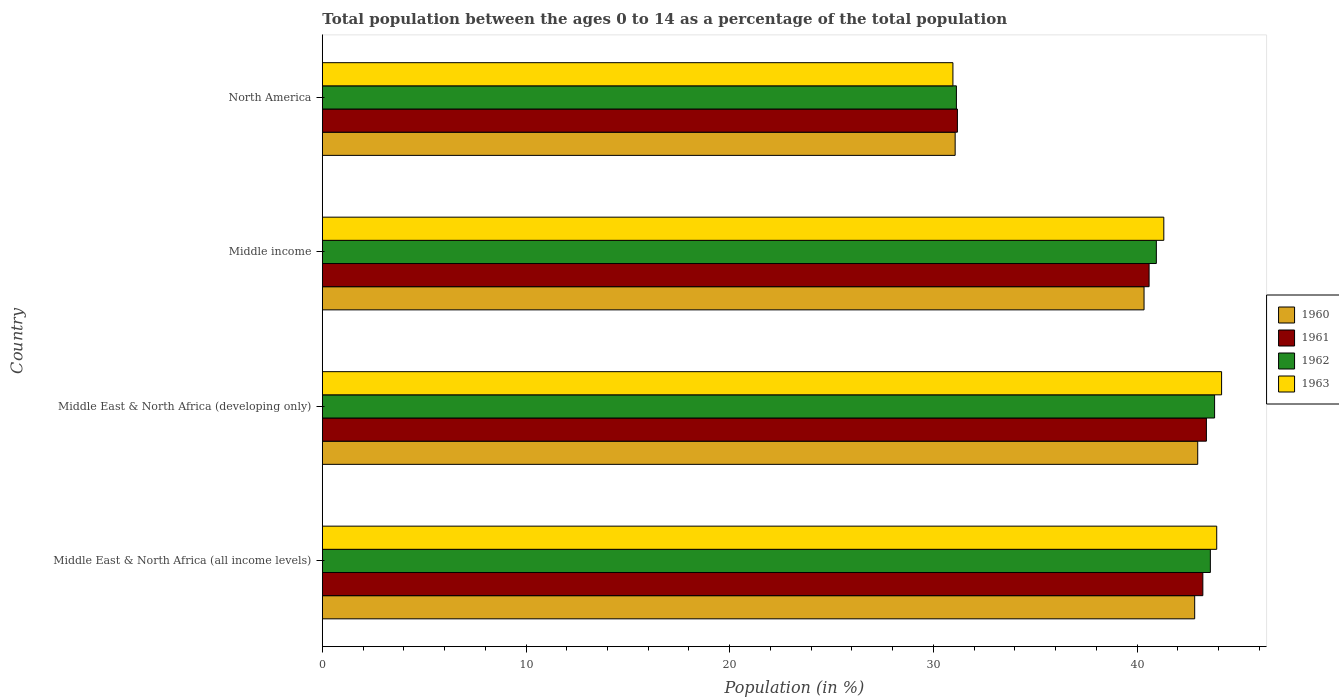How many different coloured bars are there?
Offer a terse response. 4. Are the number of bars on each tick of the Y-axis equal?
Make the answer very short. Yes. In how many cases, is the number of bars for a given country not equal to the number of legend labels?
Provide a succinct answer. 0. What is the percentage of the population ages 0 to 14 in 1961 in North America?
Your answer should be very brief. 31.18. Across all countries, what is the maximum percentage of the population ages 0 to 14 in 1960?
Ensure brevity in your answer.  42.97. Across all countries, what is the minimum percentage of the population ages 0 to 14 in 1963?
Your response must be concise. 30.96. In which country was the percentage of the population ages 0 to 14 in 1962 maximum?
Ensure brevity in your answer.  Middle East & North Africa (developing only). In which country was the percentage of the population ages 0 to 14 in 1961 minimum?
Make the answer very short. North America. What is the total percentage of the population ages 0 to 14 in 1961 in the graph?
Your answer should be very brief. 158.39. What is the difference between the percentage of the population ages 0 to 14 in 1961 in Middle East & North Africa (all income levels) and that in North America?
Provide a short and direct response. 12.05. What is the difference between the percentage of the population ages 0 to 14 in 1961 in Middle East & North Africa (all income levels) and the percentage of the population ages 0 to 14 in 1960 in Middle East & North Africa (developing only)?
Provide a short and direct response. 0.25. What is the average percentage of the population ages 0 to 14 in 1963 per country?
Provide a short and direct response. 40.08. What is the difference between the percentage of the population ages 0 to 14 in 1963 and percentage of the population ages 0 to 14 in 1962 in Middle income?
Provide a short and direct response. 0.37. In how many countries, is the percentage of the population ages 0 to 14 in 1962 greater than 38 ?
Make the answer very short. 3. What is the ratio of the percentage of the population ages 0 to 14 in 1961 in Middle East & North Africa (all income levels) to that in North America?
Your answer should be very brief. 1.39. Is the percentage of the population ages 0 to 14 in 1963 in Middle East & North Africa (all income levels) less than that in Middle East & North Africa (developing only)?
Give a very brief answer. Yes. Is the difference between the percentage of the population ages 0 to 14 in 1963 in Middle East & North Africa (all income levels) and North America greater than the difference between the percentage of the population ages 0 to 14 in 1962 in Middle East & North Africa (all income levels) and North America?
Your answer should be very brief. Yes. What is the difference between the highest and the second highest percentage of the population ages 0 to 14 in 1963?
Make the answer very short. 0.24. What is the difference between the highest and the lowest percentage of the population ages 0 to 14 in 1963?
Make the answer very short. 13.19. In how many countries, is the percentage of the population ages 0 to 14 in 1962 greater than the average percentage of the population ages 0 to 14 in 1962 taken over all countries?
Ensure brevity in your answer.  3. Is it the case that in every country, the sum of the percentage of the population ages 0 to 14 in 1960 and percentage of the population ages 0 to 14 in 1962 is greater than the sum of percentage of the population ages 0 to 14 in 1961 and percentage of the population ages 0 to 14 in 1963?
Make the answer very short. No. What does the 1st bar from the top in Middle income represents?
Ensure brevity in your answer.  1963. How many countries are there in the graph?
Your answer should be very brief. 4. What is the difference between two consecutive major ticks on the X-axis?
Provide a short and direct response. 10. Are the values on the major ticks of X-axis written in scientific E-notation?
Provide a succinct answer. No. Does the graph contain any zero values?
Ensure brevity in your answer.  No. Does the graph contain grids?
Your response must be concise. No. Where does the legend appear in the graph?
Make the answer very short. Center right. How many legend labels are there?
Your answer should be compact. 4. What is the title of the graph?
Provide a succinct answer. Total population between the ages 0 to 14 as a percentage of the total population. Does "1975" appear as one of the legend labels in the graph?
Offer a terse response. No. What is the label or title of the Y-axis?
Offer a terse response. Country. What is the Population (in %) of 1960 in Middle East & North Africa (all income levels)?
Offer a terse response. 42.83. What is the Population (in %) of 1961 in Middle East & North Africa (all income levels)?
Offer a terse response. 43.23. What is the Population (in %) of 1962 in Middle East & North Africa (all income levels)?
Offer a terse response. 43.6. What is the Population (in %) of 1963 in Middle East & North Africa (all income levels)?
Provide a succinct answer. 43.91. What is the Population (in %) in 1960 in Middle East & North Africa (developing only)?
Offer a very short reply. 42.97. What is the Population (in %) of 1961 in Middle East & North Africa (developing only)?
Keep it short and to the point. 43.4. What is the Population (in %) of 1962 in Middle East & North Africa (developing only)?
Make the answer very short. 43.8. What is the Population (in %) of 1963 in Middle East & North Africa (developing only)?
Ensure brevity in your answer.  44.15. What is the Population (in %) of 1960 in Middle income?
Offer a terse response. 40.34. What is the Population (in %) in 1961 in Middle income?
Offer a very short reply. 40.59. What is the Population (in %) in 1962 in Middle income?
Your answer should be compact. 40.94. What is the Population (in %) in 1963 in Middle income?
Your answer should be compact. 41.31. What is the Population (in %) in 1960 in North America?
Make the answer very short. 31.07. What is the Population (in %) in 1961 in North America?
Ensure brevity in your answer.  31.18. What is the Population (in %) in 1962 in North America?
Provide a succinct answer. 31.13. What is the Population (in %) in 1963 in North America?
Your response must be concise. 30.96. Across all countries, what is the maximum Population (in %) of 1960?
Offer a terse response. 42.97. Across all countries, what is the maximum Population (in %) in 1961?
Provide a succinct answer. 43.4. Across all countries, what is the maximum Population (in %) of 1962?
Keep it short and to the point. 43.8. Across all countries, what is the maximum Population (in %) in 1963?
Your answer should be compact. 44.15. Across all countries, what is the minimum Population (in %) of 1960?
Your answer should be compact. 31.07. Across all countries, what is the minimum Population (in %) in 1961?
Offer a terse response. 31.18. Across all countries, what is the minimum Population (in %) of 1962?
Offer a terse response. 31.13. Across all countries, what is the minimum Population (in %) of 1963?
Your answer should be compact. 30.96. What is the total Population (in %) of 1960 in the graph?
Offer a very short reply. 157.21. What is the total Population (in %) of 1961 in the graph?
Keep it short and to the point. 158.39. What is the total Population (in %) in 1962 in the graph?
Ensure brevity in your answer.  159.47. What is the total Population (in %) in 1963 in the graph?
Your answer should be very brief. 160.32. What is the difference between the Population (in %) in 1960 in Middle East & North Africa (all income levels) and that in Middle East & North Africa (developing only)?
Provide a succinct answer. -0.15. What is the difference between the Population (in %) in 1961 in Middle East & North Africa (all income levels) and that in Middle East & North Africa (developing only)?
Offer a very short reply. -0.17. What is the difference between the Population (in %) in 1962 in Middle East & North Africa (all income levels) and that in Middle East & North Africa (developing only)?
Make the answer very short. -0.21. What is the difference between the Population (in %) in 1963 in Middle East & North Africa (all income levels) and that in Middle East & North Africa (developing only)?
Your response must be concise. -0.24. What is the difference between the Population (in %) in 1960 in Middle East & North Africa (all income levels) and that in Middle income?
Keep it short and to the point. 2.49. What is the difference between the Population (in %) of 1961 in Middle East & North Africa (all income levels) and that in Middle income?
Ensure brevity in your answer.  2.64. What is the difference between the Population (in %) in 1962 in Middle East & North Africa (all income levels) and that in Middle income?
Your answer should be compact. 2.65. What is the difference between the Population (in %) in 1963 in Middle East & North Africa (all income levels) and that in Middle income?
Offer a terse response. 2.6. What is the difference between the Population (in %) in 1960 in Middle East & North Africa (all income levels) and that in North America?
Your response must be concise. 11.76. What is the difference between the Population (in %) in 1961 in Middle East & North Africa (all income levels) and that in North America?
Give a very brief answer. 12.05. What is the difference between the Population (in %) of 1962 in Middle East & North Africa (all income levels) and that in North America?
Make the answer very short. 12.47. What is the difference between the Population (in %) of 1963 in Middle East & North Africa (all income levels) and that in North America?
Make the answer very short. 12.95. What is the difference between the Population (in %) in 1960 in Middle East & North Africa (developing only) and that in Middle income?
Offer a terse response. 2.63. What is the difference between the Population (in %) in 1961 in Middle East & North Africa (developing only) and that in Middle income?
Your answer should be very brief. 2.81. What is the difference between the Population (in %) of 1962 in Middle East & North Africa (developing only) and that in Middle income?
Provide a short and direct response. 2.86. What is the difference between the Population (in %) of 1963 in Middle East & North Africa (developing only) and that in Middle income?
Ensure brevity in your answer.  2.84. What is the difference between the Population (in %) of 1960 in Middle East & North Africa (developing only) and that in North America?
Offer a very short reply. 11.91. What is the difference between the Population (in %) of 1961 in Middle East & North Africa (developing only) and that in North America?
Provide a short and direct response. 12.22. What is the difference between the Population (in %) of 1962 in Middle East & North Africa (developing only) and that in North America?
Your response must be concise. 12.67. What is the difference between the Population (in %) of 1963 in Middle East & North Africa (developing only) and that in North America?
Provide a succinct answer. 13.19. What is the difference between the Population (in %) in 1960 in Middle income and that in North America?
Make the answer very short. 9.27. What is the difference between the Population (in %) in 1961 in Middle income and that in North America?
Your response must be concise. 9.41. What is the difference between the Population (in %) of 1962 in Middle income and that in North America?
Make the answer very short. 9.82. What is the difference between the Population (in %) of 1963 in Middle income and that in North America?
Your answer should be compact. 10.35. What is the difference between the Population (in %) in 1960 in Middle East & North Africa (all income levels) and the Population (in %) in 1961 in Middle East & North Africa (developing only)?
Provide a short and direct response. -0.58. What is the difference between the Population (in %) in 1960 in Middle East & North Africa (all income levels) and the Population (in %) in 1962 in Middle East & North Africa (developing only)?
Make the answer very short. -0.98. What is the difference between the Population (in %) in 1960 in Middle East & North Africa (all income levels) and the Population (in %) in 1963 in Middle East & North Africa (developing only)?
Your answer should be very brief. -1.32. What is the difference between the Population (in %) of 1961 in Middle East & North Africa (all income levels) and the Population (in %) of 1962 in Middle East & North Africa (developing only)?
Keep it short and to the point. -0.58. What is the difference between the Population (in %) in 1961 in Middle East & North Africa (all income levels) and the Population (in %) in 1963 in Middle East & North Africa (developing only)?
Make the answer very short. -0.92. What is the difference between the Population (in %) in 1962 in Middle East & North Africa (all income levels) and the Population (in %) in 1963 in Middle East & North Africa (developing only)?
Your answer should be very brief. -0.55. What is the difference between the Population (in %) in 1960 in Middle East & North Africa (all income levels) and the Population (in %) in 1961 in Middle income?
Your answer should be very brief. 2.24. What is the difference between the Population (in %) of 1960 in Middle East & North Africa (all income levels) and the Population (in %) of 1962 in Middle income?
Your answer should be very brief. 1.88. What is the difference between the Population (in %) of 1960 in Middle East & North Africa (all income levels) and the Population (in %) of 1963 in Middle income?
Offer a very short reply. 1.52. What is the difference between the Population (in %) of 1961 in Middle East & North Africa (all income levels) and the Population (in %) of 1962 in Middle income?
Provide a succinct answer. 2.28. What is the difference between the Population (in %) in 1961 in Middle East & North Africa (all income levels) and the Population (in %) in 1963 in Middle income?
Your response must be concise. 1.92. What is the difference between the Population (in %) in 1962 in Middle East & North Africa (all income levels) and the Population (in %) in 1963 in Middle income?
Provide a succinct answer. 2.29. What is the difference between the Population (in %) of 1960 in Middle East & North Africa (all income levels) and the Population (in %) of 1961 in North America?
Give a very brief answer. 11.65. What is the difference between the Population (in %) in 1960 in Middle East & North Africa (all income levels) and the Population (in %) in 1962 in North America?
Ensure brevity in your answer.  11.7. What is the difference between the Population (in %) in 1960 in Middle East & North Africa (all income levels) and the Population (in %) in 1963 in North America?
Your answer should be compact. 11.87. What is the difference between the Population (in %) in 1961 in Middle East & North Africa (all income levels) and the Population (in %) in 1962 in North America?
Your response must be concise. 12.1. What is the difference between the Population (in %) in 1961 in Middle East & North Africa (all income levels) and the Population (in %) in 1963 in North America?
Your answer should be compact. 12.27. What is the difference between the Population (in %) of 1962 in Middle East & North Africa (all income levels) and the Population (in %) of 1963 in North America?
Make the answer very short. 12.64. What is the difference between the Population (in %) of 1960 in Middle East & North Africa (developing only) and the Population (in %) of 1961 in Middle income?
Your answer should be very brief. 2.39. What is the difference between the Population (in %) of 1960 in Middle East & North Africa (developing only) and the Population (in %) of 1962 in Middle income?
Your answer should be very brief. 2.03. What is the difference between the Population (in %) of 1960 in Middle East & North Africa (developing only) and the Population (in %) of 1963 in Middle income?
Provide a short and direct response. 1.66. What is the difference between the Population (in %) in 1961 in Middle East & North Africa (developing only) and the Population (in %) in 1962 in Middle income?
Provide a succinct answer. 2.46. What is the difference between the Population (in %) of 1961 in Middle East & North Africa (developing only) and the Population (in %) of 1963 in Middle income?
Ensure brevity in your answer.  2.09. What is the difference between the Population (in %) in 1962 in Middle East & North Africa (developing only) and the Population (in %) in 1963 in Middle income?
Provide a succinct answer. 2.49. What is the difference between the Population (in %) in 1960 in Middle East & North Africa (developing only) and the Population (in %) in 1961 in North America?
Make the answer very short. 11.8. What is the difference between the Population (in %) in 1960 in Middle East & North Africa (developing only) and the Population (in %) in 1962 in North America?
Provide a succinct answer. 11.85. What is the difference between the Population (in %) of 1960 in Middle East & North Africa (developing only) and the Population (in %) of 1963 in North America?
Provide a short and direct response. 12.02. What is the difference between the Population (in %) in 1961 in Middle East & North Africa (developing only) and the Population (in %) in 1962 in North America?
Provide a short and direct response. 12.27. What is the difference between the Population (in %) in 1961 in Middle East & North Africa (developing only) and the Population (in %) in 1963 in North America?
Provide a short and direct response. 12.44. What is the difference between the Population (in %) of 1962 in Middle East & North Africa (developing only) and the Population (in %) of 1963 in North America?
Offer a very short reply. 12.85. What is the difference between the Population (in %) of 1960 in Middle income and the Population (in %) of 1961 in North America?
Give a very brief answer. 9.16. What is the difference between the Population (in %) of 1960 in Middle income and the Population (in %) of 1962 in North America?
Offer a very short reply. 9.21. What is the difference between the Population (in %) in 1960 in Middle income and the Population (in %) in 1963 in North America?
Offer a very short reply. 9.38. What is the difference between the Population (in %) in 1961 in Middle income and the Population (in %) in 1962 in North America?
Offer a very short reply. 9.46. What is the difference between the Population (in %) in 1961 in Middle income and the Population (in %) in 1963 in North America?
Your response must be concise. 9.63. What is the difference between the Population (in %) in 1962 in Middle income and the Population (in %) in 1963 in North America?
Offer a terse response. 9.99. What is the average Population (in %) in 1960 per country?
Give a very brief answer. 39.3. What is the average Population (in %) in 1961 per country?
Your answer should be very brief. 39.6. What is the average Population (in %) in 1962 per country?
Make the answer very short. 39.87. What is the average Population (in %) of 1963 per country?
Offer a very short reply. 40.08. What is the difference between the Population (in %) of 1960 and Population (in %) of 1961 in Middle East & North Africa (all income levels)?
Offer a very short reply. -0.4. What is the difference between the Population (in %) in 1960 and Population (in %) in 1962 in Middle East & North Africa (all income levels)?
Give a very brief answer. -0.77. What is the difference between the Population (in %) in 1960 and Population (in %) in 1963 in Middle East & North Africa (all income levels)?
Your answer should be very brief. -1.08. What is the difference between the Population (in %) in 1961 and Population (in %) in 1962 in Middle East & North Africa (all income levels)?
Keep it short and to the point. -0.37. What is the difference between the Population (in %) in 1961 and Population (in %) in 1963 in Middle East & North Africa (all income levels)?
Give a very brief answer. -0.68. What is the difference between the Population (in %) in 1962 and Population (in %) in 1963 in Middle East & North Africa (all income levels)?
Offer a terse response. -0.31. What is the difference between the Population (in %) of 1960 and Population (in %) of 1961 in Middle East & North Africa (developing only)?
Your answer should be very brief. -0.43. What is the difference between the Population (in %) in 1960 and Population (in %) in 1962 in Middle East & North Africa (developing only)?
Offer a very short reply. -0.83. What is the difference between the Population (in %) in 1960 and Population (in %) in 1963 in Middle East & North Africa (developing only)?
Offer a very short reply. -1.17. What is the difference between the Population (in %) in 1961 and Population (in %) in 1962 in Middle East & North Africa (developing only)?
Ensure brevity in your answer.  -0.4. What is the difference between the Population (in %) of 1961 and Population (in %) of 1963 in Middle East & North Africa (developing only)?
Provide a succinct answer. -0.75. What is the difference between the Population (in %) in 1962 and Population (in %) in 1963 in Middle East & North Africa (developing only)?
Your answer should be very brief. -0.34. What is the difference between the Population (in %) in 1960 and Population (in %) in 1961 in Middle income?
Provide a succinct answer. -0.25. What is the difference between the Population (in %) in 1960 and Population (in %) in 1962 in Middle income?
Provide a short and direct response. -0.6. What is the difference between the Population (in %) of 1960 and Population (in %) of 1963 in Middle income?
Offer a terse response. -0.97. What is the difference between the Population (in %) in 1961 and Population (in %) in 1962 in Middle income?
Give a very brief answer. -0.36. What is the difference between the Population (in %) in 1961 and Population (in %) in 1963 in Middle income?
Make the answer very short. -0.72. What is the difference between the Population (in %) of 1962 and Population (in %) of 1963 in Middle income?
Offer a very short reply. -0.37. What is the difference between the Population (in %) in 1960 and Population (in %) in 1961 in North America?
Ensure brevity in your answer.  -0.11. What is the difference between the Population (in %) in 1960 and Population (in %) in 1962 in North America?
Your answer should be very brief. -0.06. What is the difference between the Population (in %) in 1960 and Population (in %) in 1963 in North America?
Offer a terse response. 0.11. What is the difference between the Population (in %) of 1961 and Population (in %) of 1962 in North America?
Make the answer very short. 0.05. What is the difference between the Population (in %) of 1961 and Population (in %) of 1963 in North America?
Offer a very short reply. 0.22. What is the difference between the Population (in %) of 1962 and Population (in %) of 1963 in North America?
Make the answer very short. 0.17. What is the ratio of the Population (in %) of 1960 in Middle East & North Africa (all income levels) to that in Middle East & North Africa (developing only)?
Make the answer very short. 1. What is the ratio of the Population (in %) of 1961 in Middle East & North Africa (all income levels) to that in Middle East & North Africa (developing only)?
Keep it short and to the point. 1. What is the ratio of the Population (in %) of 1960 in Middle East & North Africa (all income levels) to that in Middle income?
Your answer should be compact. 1.06. What is the ratio of the Population (in %) in 1961 in Middle East & North Africa (all income levels) to that in Middle income?
Provide a short and direct response. 1.06. What is the ratio of the Population (in %) in 1962 in Middle East & North Africa (all income levels) to that in Middle income?
Keep it short and to the point. 1.06. What is the ratio of the Population (in %) in 1963 in Middle East & North Africa (all income levels) to that in Middle income?
Your answer should be compact. 1.06. What is the ratio of the Population (in %) in 1960 in Middle East & North Africa (all income levels) to that in North America?
Offer a very short reply. 1.38. What is the ratio of the Population (in %) of 1961 in Middle East & North Africa (all income levels) to that in North America?
Provide a short and direct response. 1.39. What is the ratio of the Population (in %) in 1962 in Middle East & North Africa (all income levels) to that in North America?
Your answer should be compact. 1.4. What is the ratio of the Population (in %) of 1963 in Middle East & North Africa (all income levels) to that in North America?
Keep it short and to the point. 1.42. What is the ratio of the Population (in %) of 1960 in Middle East & North Africa (developing only) to that in Middle income?
Give a very brief answer. 1.07. What is the ratio of the Population (in %) in 1961 in Middle East & North Africa (developing only) to that in Middle income?
Offer a terse response. 1.07. What is the ratio of the Population (in %) in 1962 in Middle East & North Africa (developing only) to that in Middle income?
Offer a terse response. 1.07. What is the ratio of the Population (in %) in 1963 in Middle East & North Africa (developing only) to that in Middle income?
Keep it short and to the point. 1.07. What is the ratio of the Population (in %) in 1960 in Middle East & North Africa (developing only) to that in North America?
Your response must be concise. 1.38. What is the ratio of the Population (in %) in 1961 in Middle East & North Africa (developing only) to that in North America?
Your answer should be very brief. 1.39. What is the ratio of the Population (in %) in 1962 in Middle East & North Africa (developing only) to that in North America?
Your answer should be very brief. 1.41. What is the ratio of the Population (in %) of 1963 in Middle East & North Africa (developing only) to that in North America?
Provide a short and direct response. 1.43. What is the ratio of the Population (in %) of 1960 in Middle income to that in North America?
Offer a terse response. 1.3. What is the ratio of the Population (in %) of 1961 in Middle income to that in North America?
Provide a succinct answer. 1.3. What is the ratio of the Population (in %) in 1962 in Middle income to that in North America?
Your response must be concise. 1.32. What is the ratio of the Population (in %) in 1963 in Middle income to that in North America?
Offer a very short reply. 1.33. What is the difference between the highest and the second highest Population (in %) in 1960?
Make the answer very short. 0.15. What is the difference between the highest and the second highest Population (in %) in 1961?
Your answer should be very brief. 0.17. What is the difference between the highest and the second highest Population (in %) in 1962?
Provide a succinct answer. 0.21. What is the difference between the highest and the second highest Population (in %) of 1963?
Your answer should be compact. 0.24. What is the difference between the highest and the lowest Population (in %) in 1960?
Keep it short and to the point. 11.91. What is the difference between the highest and the lowest Population (in %) in 1961?
Make the answer very short. 12.22. What is the difference between the highest and the lowest Population (in %) in 1962?
Provide a short and direct response. 12.67. What is the difference between the highest and the lowest Population (in %) of 1963?
Provide a short and direct response. 13.19. 